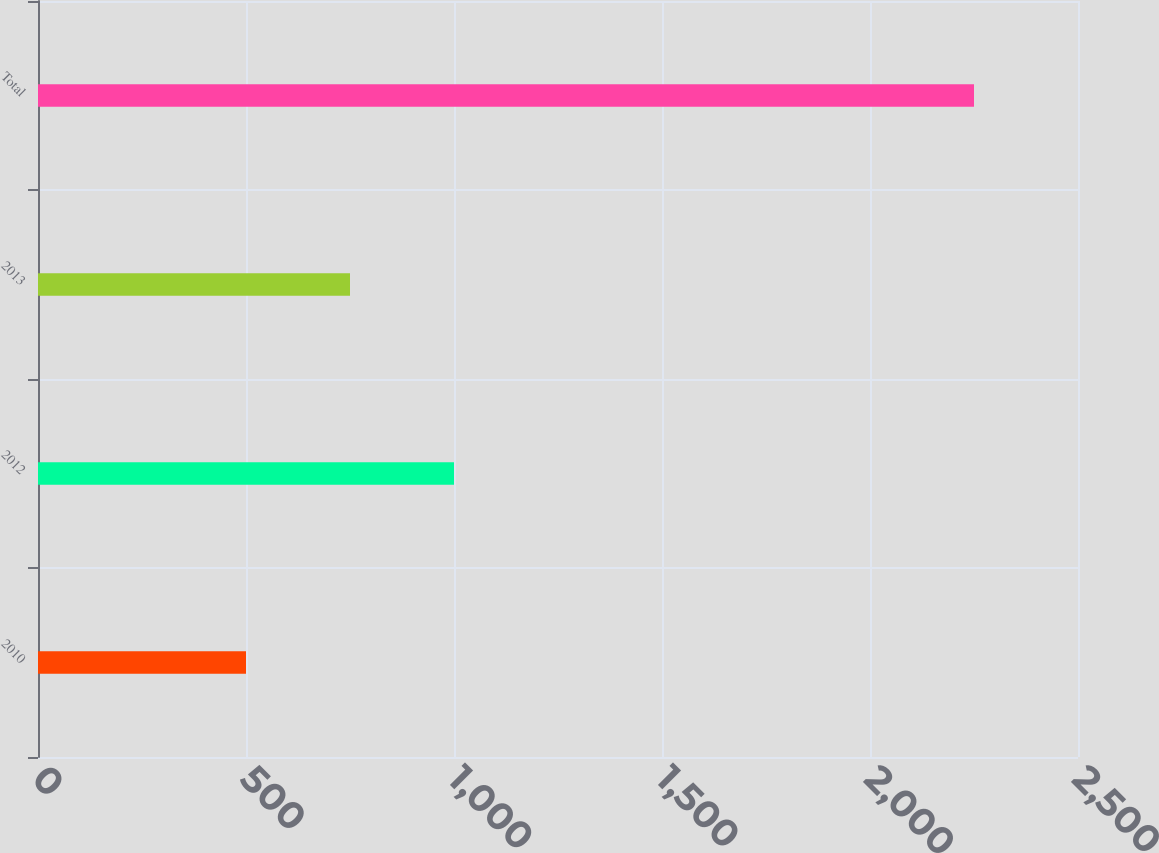Convert chart to OTSL. <chart><loc_0><loc_0><loc_500><loc_500><bar_chart><fcel>2010<fcel>2012<fcel>2013<fcel>Total<nl><fcel>500<fcel>1000<fcel>750<fcel>2250<nl></chart> 